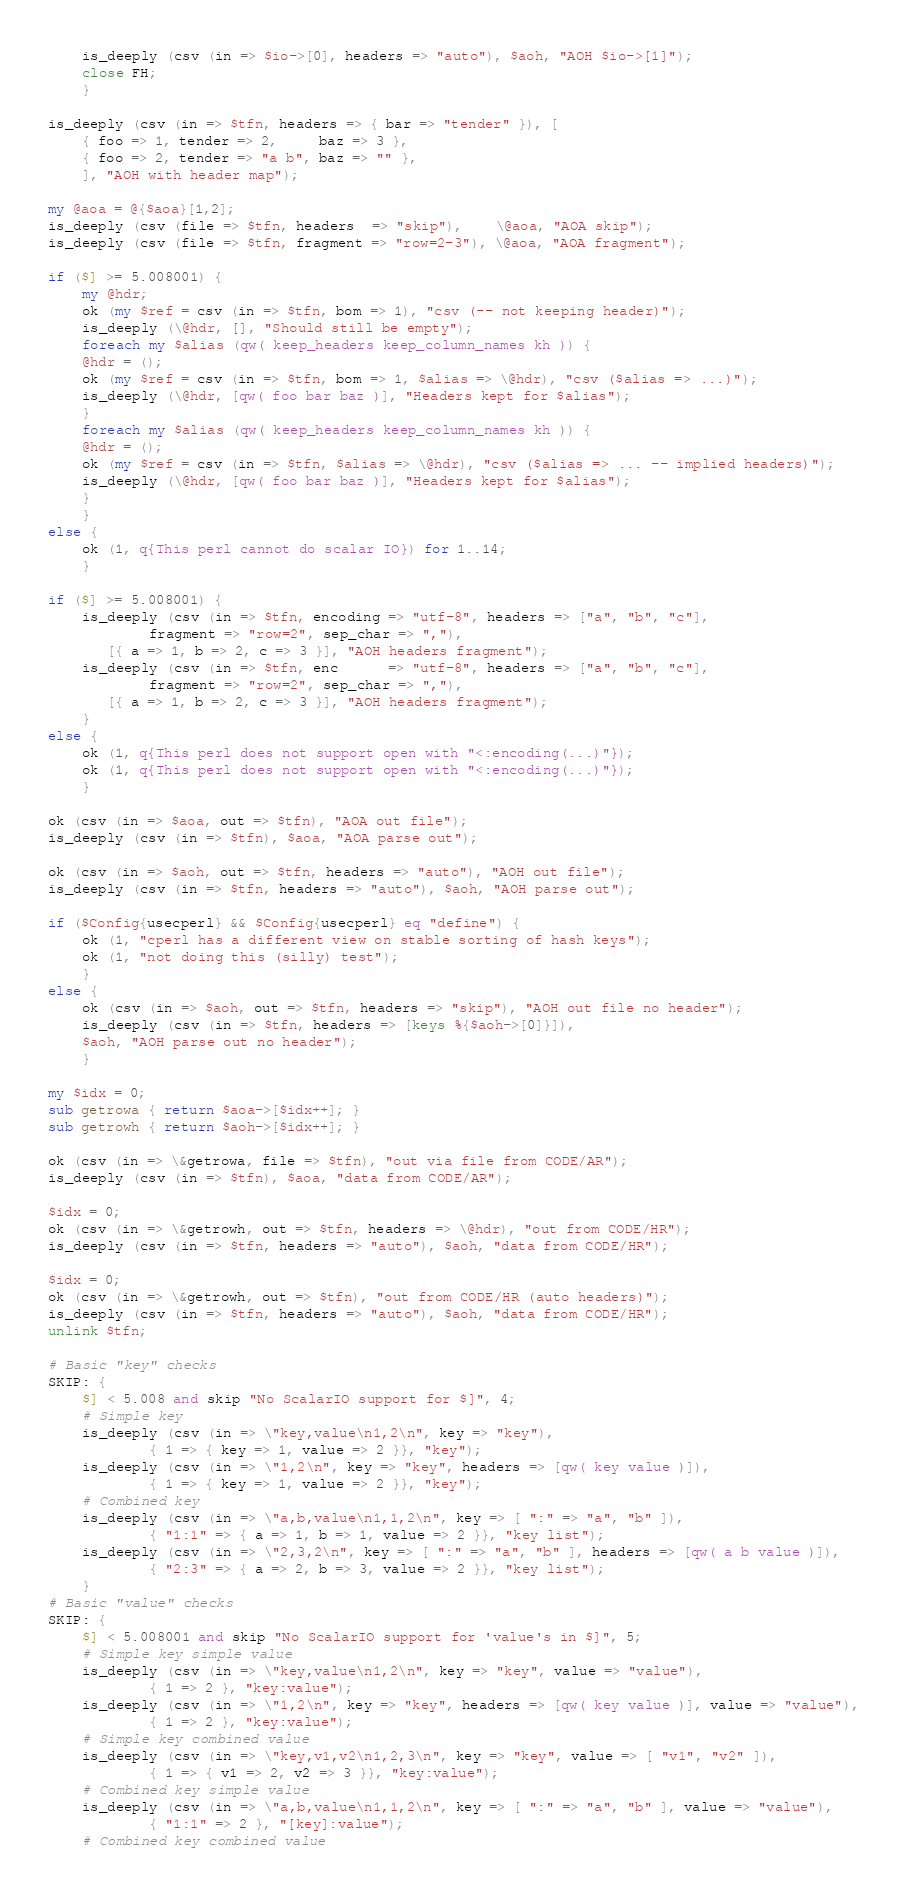<code> <loc_0><loc_0><loc_500><loc_500><_Perl_>    is_deeply (csv (in => $io->[0], headers => "auto"), $aoh, "AOH $io->[1]");
    close FH;
    }

is_deeply (csv (in => $tfn, headers => { bar => "tender" }), [
    { foo => 1, tender => 2,     baz => 3 },
    { foo => 2, tender => "a b", baz => "" },
    ], "AOH with header map");

my @aoa = @{$aoa}[1,2];
is_deeply (csv (file => $tfn, headers  => "skip"),    \@aoa, "AOA skip");
is_deeply (csv (file => $tfn, fragment => "row=2-3"), \@aoa, "AOA fragment");

if ($] >= 5.008001) {
    my @hdr;
    ok (my $ref = csv (in => $tfn, bom => 1), "csv (-- not keeping header)");
    is_deeply (\@hdr, [], "Should still be empty");
    foreach my $alias (qw( keep_headers keep_column_names kh )) {
	@hdr = ();
	ok (my $ref = csv (in => $tfn, bom => 1, $alias => \@hdr), "csv ($alias => ...)");
	is_deeply (\@hdr, [qw( foo bar baz )], "Headers kept for $alias");
	}
    foreach my $alias (qw( keep_headers keep_column_names kh )) {
	@hdr = ();
	ok (my $ref = csv (in => $tfn, $alias => \@hdr), "csv ($alias => ... -- implied headers)");
	is_deeply (\@hdr, [qw( foo bar baz )], "Headers kept for $alias");
	}
    }
else {
    ok (1, q{This perl cannot do scalar IO}) for 1..14;
    }

if ($] >= 5.008001) {
    is_deeply (csv (in => $tfn, encoding => "utf-8", headers => ["a", "b", "c"],
		    fragment => "row=2", sep_char => ","),
	   [{ a => 1, b => 2, c => 3 }], "AOH headers fragment");
    is_deeply (csv (in => $tfn, enc      => "utf-8", headers => ["a", "b", "c"],
		    fragment => "row=2", sep_char => ","),
	   [{ a => 1, b => 2, c => 3 }], "AOH headers fragment");
    }
else {
    ok (1, q{This perl does not support open with "<:encoding(...)"});
    ok (1, q{This perl does not support open with "<:encoding(...)"});
    }

ok (csv (in => $aoa, out => $tfn), "AOA out file");
is_deeply (csv (in => $tfn), $aoa, "AOA parse out");

ok (csv (in => $aoh, out => $tfn, headers => "auto"), "AOH out file");
is_deeply (csv (in => $tfn, headers => "auto"), $aoh, "AOH parse out");

if ($Config{usecperl} && $Config{usecperl} eq "define") {
    ok (1, "cperl has a different view on stable sorting of hash keys");
    ok (1, "not doing this (silly) test");
    }
else {
    ok (csv (in => $aoh, out => $tfn, headers => "skip"), "AOH out file no header");
    is_deeply (csv (in => $tfn, headers => [keys %{$aoh->[0]}]),
	$aoh, "AOH parse out no header");
    }

my $idx = 0;
sub getrowa { return $aoa->[$idx++]; }
sub getrowh { return $aoh->[$idx++]; }

ok (csv (in => \&getrowa, file => $tfn), "out via file from CODE/AR");
is_deeply (csv (in => $tfn), $aoa, "data from CODE/AR");

$idx = 0;
ok (csv (in => \&getrowh, out => $tfn, headers => \@hdr), "out from CODE/HR");
is_deeply (csv (in => $tfn, headers => "auto"), $aoh, "data from CODE/HR");

$idx = 0;
ok (csv (in => \&getrowh, out => $tfn), "out from CODE/HR (auto headers)");
is_deeply (csv (in => $tfn, headers => "auto"), $aoh, "data from CODE/HR");
unlink $tfn;

# Basic "key" checks
SKIP: {
    $] < 5.008 and skip "No ScalarIO support for $]", 4;
    # Simple key
    is_deeply (csv (in => \"key,value\n1,2\n", key => "key"),
		    { 1 => { key => 1, value => 2 }}, "key");
    is_deeply (csv (in => \"1,2\n", key => "key", headers => [qw( key value )]),
		    { 1 => { key => 1, value => 2 }}, "key");
    # Combined key
    is_deeply (csv (in => \"a,b,value\n1,1,2\n", key => [ ":" => "a", "b" ]),
		    { "1:1" => { a => 1, b => 1, value => 2 }}, "key list");
    is_deeply (csv (in => \"2,3,2\n", key => [ ":" => "a", "b" ], headers => [qw( a b value )]),
		    { "2:3" => { a => 2, b => 3, value => 2 }}, "key list");
    }
# Basic "value" checks
SKIP: {
    $] < 5.008001 and skip "No ScalarIO support for 'value's in $]", 5;
    # Simple key simple value
    is_deeply (csv (in => \"key,value\n1,2\n", key => "key", value => "value"),
		    { 1 => 2 }, "key:value");
    is_deeply (csv (in => \"1,2\n", key => "key", headers => [qw( key value )], value => "value"),
		    { 1 => 2 }, "key:value");
    # Simple key combined value
    is_deeply (csv (in => \"key,v1,v2\n1,2,3\n", key => "key", value => [ "v1", "v2" ]),
		    { 1 => { v1 => 2, v2 => 3 }}, "key:value");
    # Combined key simple value
    is_deeply (csv (in => \"a,b,value\n1,1,2\n", key => [ ":" => "a", "b" ], value => "value"),
		    { "1:1" => 2 }, "[key]:value");
    # Combined key combined value</code> 